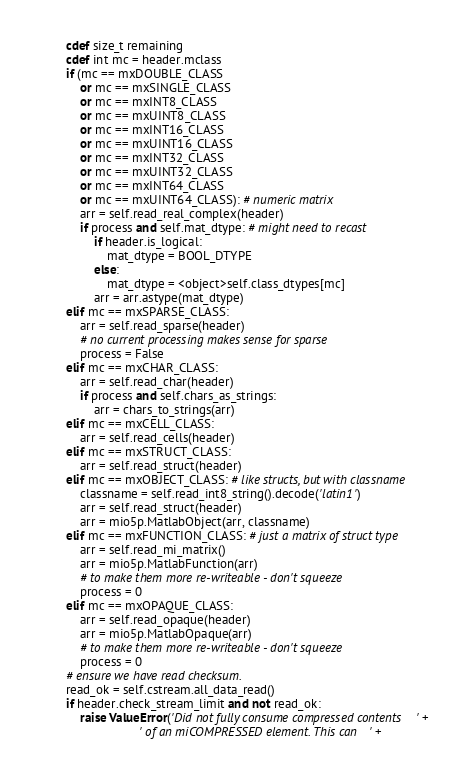Convert code to text. <code><loc_0><loc_0><loc_500><loc_500><_Cython_>        cdef size_t remaining
        cdef int mc = header.mclass
        if (mc == mxDOUBLE_CLASS
            or mc == mxSINGLE_CLASS
            or mc == mxINT8_CLASS
            or mc == mxUINT8_CLASS
            or mc == mxINT16_CLASS
            or mc == mxUINT16_CLASS
            or mc == mxINT32_CLASS
            or mc == mxUINT32_CLASS
            or mc == mxINT64_CLASS
            or mc == mxUINT64_CLASS): # numeric matrix
            arr = self.read_real_complex(header)
            if process and self.mat_dtype: # might need to recast
                if header.is_logical:
                    mat_dtype = BOOL_DTYPE
                else:
                    mat_dtype = <object>self.class_dtypes[mc]
                arr = arr.astype(mat_dtype)
        elif mc == mxSPARSE_CLASS:
            arr = self.read_sparse(header)
            # no current processing makes sense for sparse
            process = False
        elif mc == mxCHAR_CLASS:
            arr = self.read_char(header)
            if process and self.chars_as_strings:
                arr = chars_to_strings(arr)
        elif mc == mxCELL_CLASS:
            arr = self.read_cells(header)
        elif mc == mxSTRUCT_CLASS:
            arr = self.read_struct(header)
        elif mc == mxOBJECT_CLASS: # like structs, but with classname
            classname = self.read_int8_string().decode('latin1')
            arr = self.read_struct(header)
            arr = mio5p.MatlabObject(arr, classname)
        elif mc == mxFUNCTION_CLASS: # just a matrix of struct type
            arr = self.read_mi_matrix()
            arr = mio5p.MatlabFunction(arr)
            # to make them more re-writeable - don't squeeze
            process = 0
        elif mc == mxOPAQUE_CLASS:
            arr = self.read_opaque(header)
            arr = mio5p.MatlabOpaque(arr)
            # to make them more re-writeable - don't squeeze
            process = 0
        # ensure we have read checksum.
        read_ok = self.cstream.all_data_read()
        if header.check_stream_limit and not read_ok:
            raise ValueError('Did not fully consume compressed contents' +
                             ' of an miCOMPRESSED element. This can' +</code> 